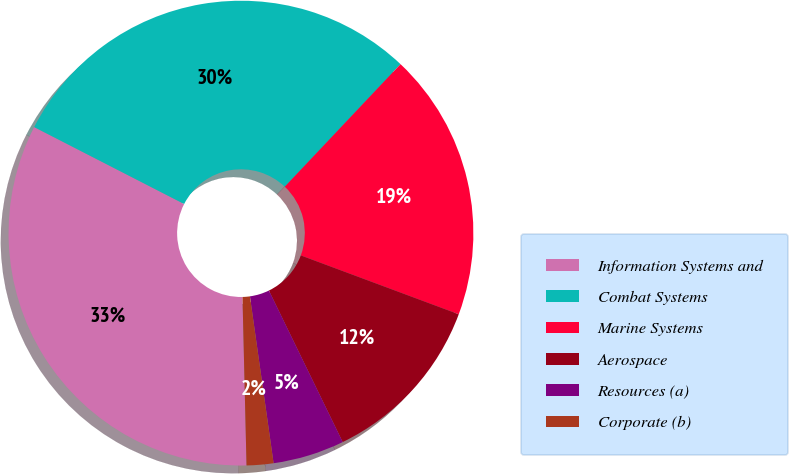Convert chart to OTSL. <chart><loc_0><loc_0><loc_500><loc_500><pie_chart><fcel>Information Systems and<fcel>Combat Systems<fcel>Marine Systems<fcel>Aerospace<fcel>Resources (a)<fcel>Corporate (b)<nl><fcel>32.92%<fcel>29.5%<fcel>18.63%<fcel>12.11%<fcel>4.97%<fcel>1.86%<nl></chart> 